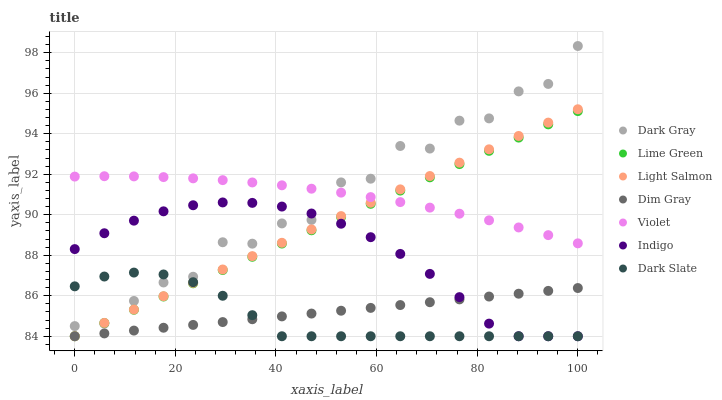Does Dark Slate have the minimum area under the curve?
Answer yes or no. Yes. Does Violet have the maximum area under the curve?
Answer yes or no. Yes. Does Dim Gray have the minimum area under the curve?
Answer yes or no. No. Does Dim Gray have the maximum area under the curve?
Answer yes or no. No. Is Lime Green the smoothest?
Answer yes or no. Yes. Is Dark Gray the roughest?
Answer yes or no. Yes. Is Dim Gray the smoothest?
Answer yes or no. No. Is Dim Gray the roughest?
Answer yes or no. No. Does Light Salmon have the lowest value?
Answer yes or no. Yes. Does Dark Gray have the lowest value?
Answer yes or no. No. Does Dark Gray have the highest value?
Answer yes or no. Yes. Does Indigo have the highest value?
Answer yes or no. No. Is Dim Gray less than Violet?
Answer yes or no. Yes. Is Dark Gray greater than Dim Gray?
Answer yes or no. Yes. Does Dark Gray intersect Lime Green?
Answer yes or no. Yes. Is Dark Gray less than Lime Green?
Answer yes or no. No. Is Dark Gray greater than Lime Green?
Answer yes or no. No. Does Dim Gray intersect Violet?
Answer yes or no. No. 